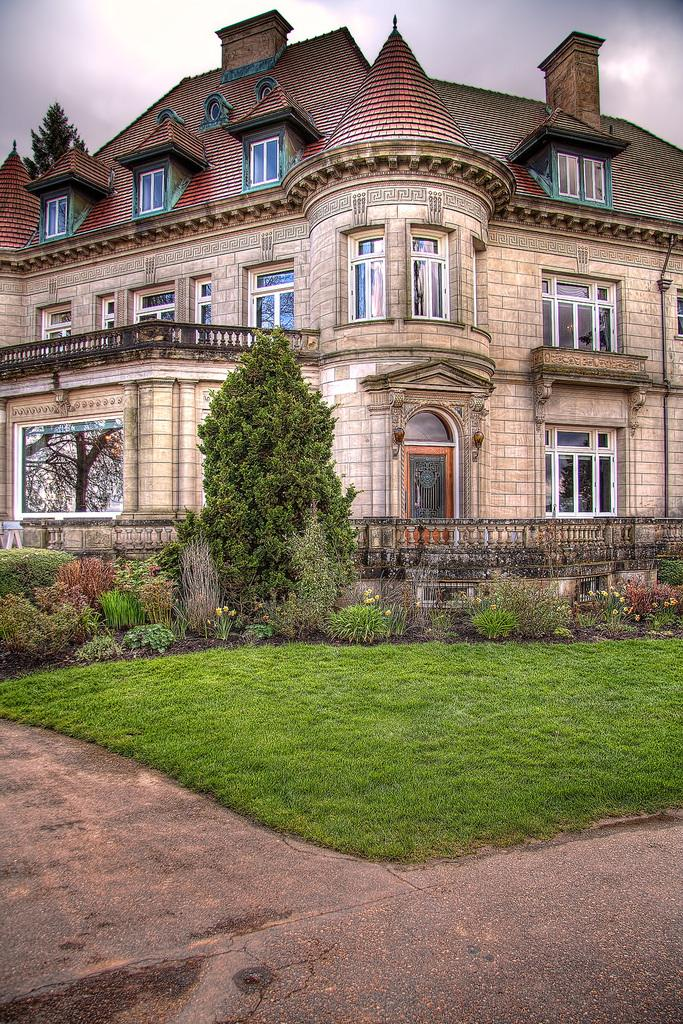What is at the bottom of the image? There is a road at the bottom of the image. What type of vegetation can be seen on the ground in the image? There is grass on the ground in the image. What can be seen in the background of the image? There are trees, plants, at least one building, windows, a door, a roof, a fence, and other objects in the background of the image. What is visible in the sky in the background of the image? Clouds are visible in the sky in the background of the image. What type of silk is being used to reward the cook in the image? There is no silk, reward, or cook present in the image. 